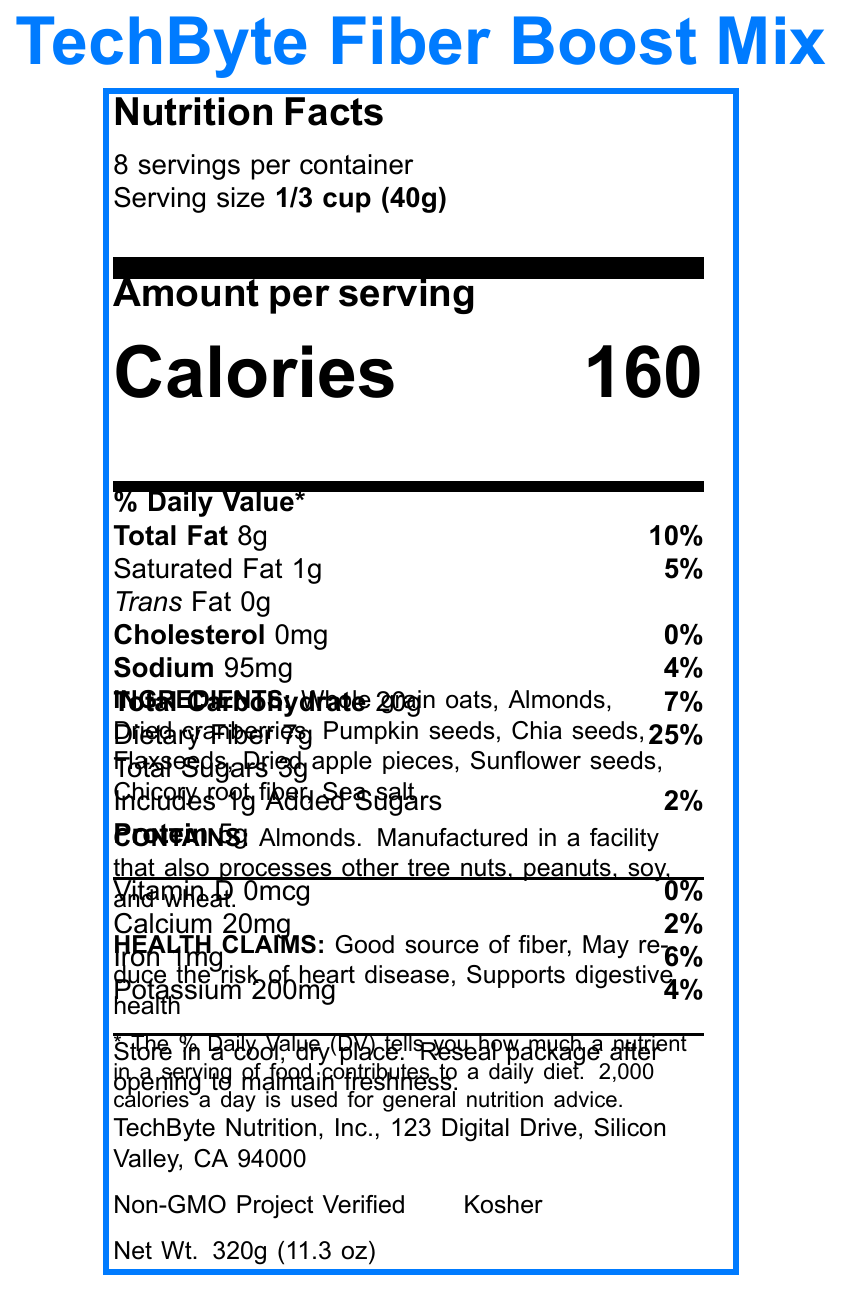what is the serving size of TechByte Fiber Boost Mix? The serving size is listed at the top of the Nutrition Facts section as "Serving size 1/3 cup (40g)".
Answer: 1/3 cup (40g) how many calories are in one serving? The number of calories per serving is clearly displayed as "Calories 160" in the document.
Answer: 160 what percentage of the daily value of dietary fiber does one serving provide? This information is listed under the Total Carbohydrate section, showing "Dietary Fiber 7g 25%".
Answer: 25% which ingredient indicates that the product contains a potential allergen? This is stated in the allergen information and ingredient list: "Contains: Almonds".
Answer: Almonds where is this product manufactured? The manufacturer information at the bottom lists "TechByte Nutrition, Inc., 123 Digital Drive, Silicon Valley, CA 94000".
Answer: Silicon Valley, CA 94000 does TechByte Fiber Boost Mix contain any trans fat? The document states "Trans Fat 0g," indicating there is no trans fat in the product.
Answer: No how many servings are in the container? The document clearly states "8 servings per container."
Answer: 8 what are the certifications obtained by TechByte Fiber Boost Mix? These are listed at the bottom of the document under certifications.
Answer: Non-GMO Project Verified, Kosher which mineral is present in the highest quantity per serving? A. Calcium B. Iron C. Potassium The amounts of calcium, iron, and potassium per serving are 20mg, 1mg and 200mg respectively, with potassium being the highest.
Answer: C. Potassium what is the percentage of daily value for sodium in each serving? A. 5% B. 10% C. 4% The document lists sodium as "Sodium 95mg 4%" which translates to 4% of the daily value.
Answer: C. 4% does one serving of TechByte Fiber Boost Mix contain added sugars? The document specifies "Includes 1g Added Sugars 2%" under the Total Sugars section.
Answer: Yes summarize the main idea of the TechByte Fiber Boost Mix Nutrition Facts label. The Nutrition Facts label gives detailed nutrient information per serving, lists the ingredients and allergens, and mentions various health benefits and certifications.
Answer: TechByte Fiber Boost Mix is a fiber-rich snack designed for IT professionals, providing 160 calories per serving, with 25% of the daily value for dietary fiber, and containing healthy ingredients like oats, almonds, and seeds. It has several health claims, including supporting digestive health, and is certified as Non-GMO and Kosher. what is the total fat amount in one serving of the mix? This is listed in the Total Fat section: "Total Fat 8g 10%."
Answer: 8g how should this product be stored? These storage instructions are provided in the document.
Answer: Store in a cool, dry place. Reseal package after opening to maintain freshness. which company manufactures TechByte Fiber Boost Mix? The manufacturer information at the bottom states "TechByte Nutrition, Inc."
Answer: TechByte Nutrition, Inc. how much protein is there in each serving? The amount of protein per serving is listed as "Protein 5g."
Answer: 5g does the product contain any vitamin D? The Nutrition Facts shows "Vitamin D 0mcg 0%", indicating there isn't any.
Answer: No what is the net weight of the TechByte Fiber Boost Mix container? This information is listed at the bottom of the document: "Net Wt. 320g (11.3 oz)."
Answer: 320g (11.3 oz) are there any ingredients mentioned that are known to support digestive health? Chicory root fiber is one of the ingredients known for supporting digestive health.
Answer: Yes can you determine the cost of the TechByte Fiber Boost Mix from this document? The document does not provide any information related to the cost or price of the product.
Answer: Not enough information 